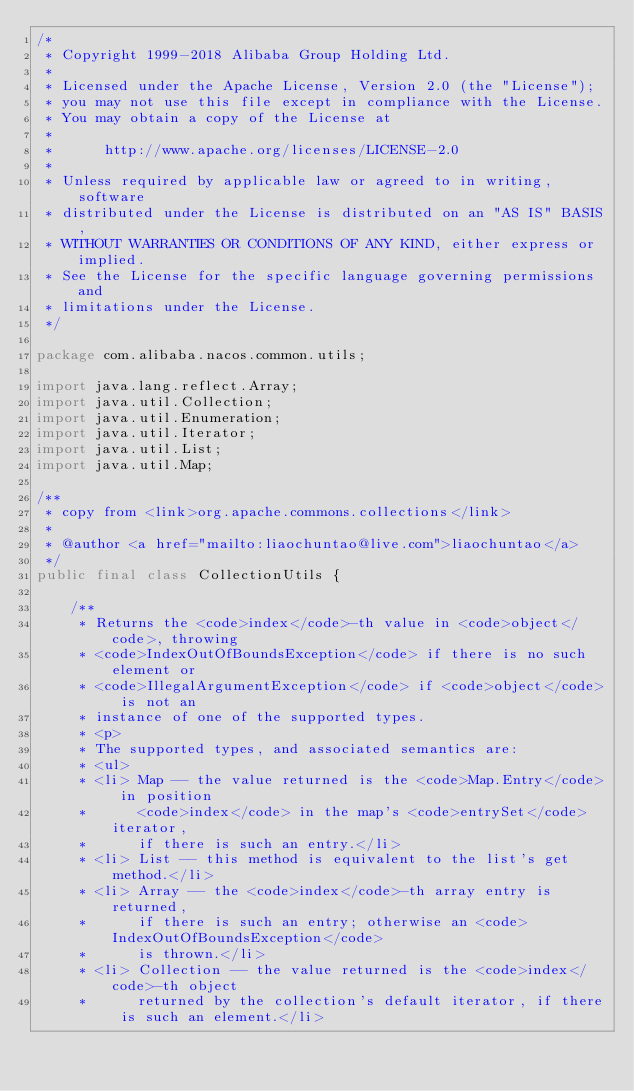Convert code to text. <code><loc_0><loc_0><loc_500><loc_500><_Java_>/*
 * Copyright 1999-2018 Alibaba Group Holding Ltd.
 *
 * Licensed under the Apache License, Version 2.0 (the "License");
 * you may not use this file except in compliance with the License.
 * You may obtain a copy of the License at
 *
 *      http://www.apache.org/licenses/LICENSE-2.0
 *
 * Unless required by applicable law or agreed to in writing, software
 * distributed under the License is distributed on an "AS IS" BASIS,
 * WITHOUT WARRANTIES OR CONDITIONS OF ANY KIND, either express or implied.
 * See the License for the specific language governing permissions and
 * limitations under the License.
 */

package com.alibaba.nacos.common.utils;

import java.lang.reflect.Array;
import java.util.Collection;
import java.util.Enumeration;
import java.util.Iterator;
import java.util.List;
import java.util.Map;

/**
 * copy from <link>org.apache.commons.collections</link>
 *
 * @author <a href="mailto:liaochuntao@live.com">liaochuntao</a>
 */
public final class CollectionUtils {

	/**
	 * Returns the <code>index</code>-th value in <code>object</code>, throwing
	 * <code>IndexOutOfBoundsException</code> if there is no such element or
	 * <code>IllegalArgumentException</code> if <code>object</code> is not an
	 * instance of one of the supported types.
	 * <p>
	 * The supported types, and associated semantics are:
	 * <ul>
	 * <li> Map -- the value returned is the <code>Map.Entry</code> in position
	 *      <code>index</code> in the map's <code>entrySet</code> iterator,
	 *      if there is such an entry.</li>
	 * <li> List -- this method is equivalent to the list's get method.</li>
	 * <li> Array -- the <code>index</code>-th array entry is returned,
	 *      if there is such an entry; otherwise an <code>IndexOutOfBoundsException</code>
	 *      is thrown.</li>
	 * <li> Collection -- the value returned is the <code>index</code>-th object
	 *      returned by the collection's default iterator, if there is such an element.</li></code> 